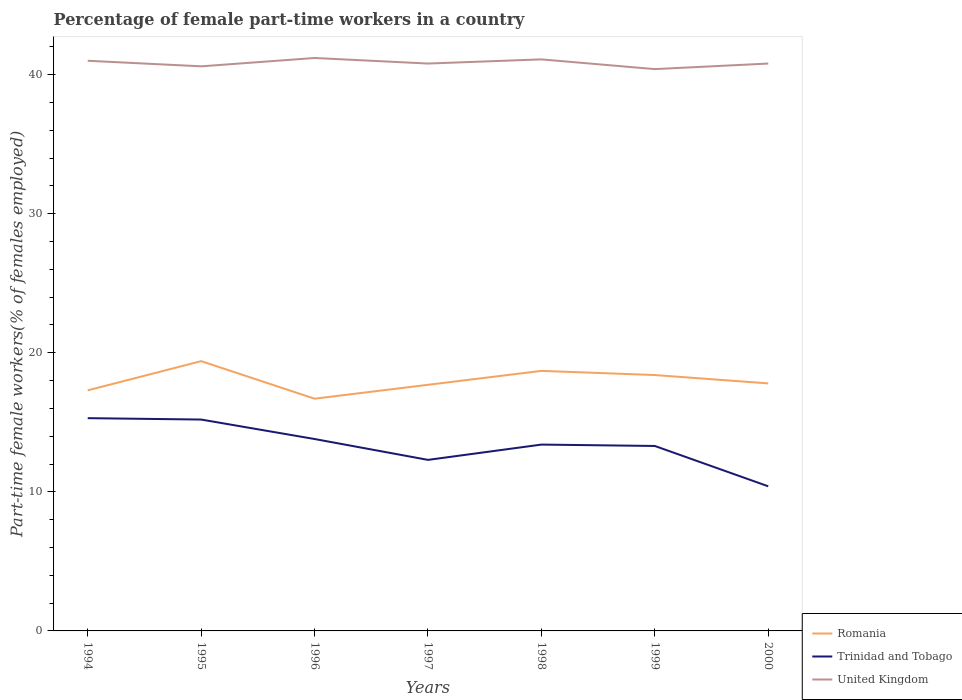Does the line corresponding to Trinidad and Tobago intersect with the line corresponding to Romania?
Provide a short and direct response. No. Is the number of lines equal to the number of legend labels?
Your response must be concise. Yes. Across all years, what is the maximum percentage of female part-time workers in Trinidad and Tobago?
Offer a very short reply. 10.4. In which year was the percentage of female part-time workers in Romania maximum?
Your answer should be compact. 1996. What is the total percentage of female part-time workers in United Kingdom in the graph?
Provide a short and direct response. -0.6. What is the difference between the highest and the second highest percentage of female part-time workers in Trinidad and Tobago?
Your answer should be very brief. 4.9. What is the difference between the highest and the lowest percentage of female part-time workers in Trinidad and Tobago?
Offer a terse response. 4. What is the difference between two consecutive major ticks on the Y-axis?
Give a very brief answer. 10. Are the values on the major ticks of Y-axis written in scientific E-notation?
Ensure brevity in your answer.  No. Does the graph contain grids?
Provide a short and direct response. No. How many legend labels are there?
Your answer should be compact. 3. What is the title of the graph?
Make the answer very short. Percentage of female part-time workers in a country. What is the label or title of the Y-axis?
Provide a succinct answer. Part-time female workers(% of females employed). What is the Part-time female workers(% of females employed) of Romania in 1994?
Ensure brevity in your answer.  17.3. What is the Part-time female workers(% of females employed) in Trinidad and Tobago in 1994?
Your answer should be compact. 15.3. What is the Part-time female workers(% of females employed) in Romania in 1995?
Provide a short and direct response. 19.4. What is the Part-time female workers(% of females employed) of Trinidad and Tobago in 1995?
Provide a succinct answer. 15.2. What is the Part-time female workers(% of females employed) of United Kingdom in 1995?
Your response must be concise. 40.6. What is the Part-time female workers(% of females employed) of Romania in 1996?
Ensure brevity in your answer.  16.7. What is the Part-time female workers(% of females employed) in Trinidad and Tobago in 1996?
Provide a short and direct response. 13.8. What is the Part-time female workers(% of females employed) in United Kingdom in 1996?
Your answer should be compact. 41.2. What is the Part-time female workers(% of females employed) in Romania in 1997?
Make the answer very short. 17.7. What is the Part-time female workers(% of females employed) of Trinidad and Tobago in 1997?
Your answer should be compact. 12.3. What is the Part-time female workers(% of females employed) in United Kingdom in 1997?
Make the answer very short. 40.8. What is the Part-time female workers(% of females employed) of Romania in 1998?
Your answer should be very brief. 18.7. What is the Part-time female workers(% of females employed) of Trinidad and Tobago in 1998?
Provide a succinct answer. 13.4. What is the Part-time female workers(% of females employed) in United Kingdom in 1998?
Keep it short and to the point. 41.1. What is the Part-time female workers(% of females employed) in Romania in 1999?
Give a very brief answer. 18.4. What is the Part-time female workers(% of females employed) of Trinidad and Tobago in 1999?
Offer a terse response. 13.3. What is the Part-time female workers(% of females employed) in United Kingdom in 1999?
Provide a succinct answer. 40.4. What is the Part-time female workers(% of females employed) of Romania in 2000?
Keep it short and to the point. 17.8. What is the Part-time female workers(% of females employed) of Trinidad and Tobago in 2000?
Provide a succinct answer. 10.4. What is the Part-time female workers(% of females employed) of United Kingdom in 2000?
Ensure brevity in your answer.  40.8. Across all years, what is the maximum Part-time female workers(% of females employed) of Romania?
Your response must be concise. 19.4. Across all years, what is the maximum Part-time female workers(% of females employed) of Trinidad and Tobago?
Make the answer very short. 15.3. Across all years, what is the maximum Part-time female workers(% of females employed) in United Kingdom?
Your response must be concise. 41.2. Across all years, what is the minimum Part-time female workers(% of females employed) in Romania?
Your answer should be compact. 16.7. Across all years, what is the minimum Part-time female workers(% of females employed) in Trinidad and Tobago?
Your answer should be compact. 10.4. Across all years, what is the minimum Part-time female workers(% of females employed) in United Kingdom?
Provide a short and direct response. 40.4. What is the total Part-time female workers(% of females employed) in Romania in the graph?
Your answer should be compact. 126. What is the total Part-time female workers(% of females employed) of Trinidad and Tobago in the graph?
Make the answer very short. 93.7. What is the total Part-time female workers(% of females employed) in United Kingdom in the graph?
Make the answer very short. 285.9. What is the difference between the Part-time female workers(% of females employed) in Romania in 1994 and that in 1995?
Your response must be concise. -2.1. What is the difference between the Part-time female workers(% of females employed) of Trinidad and Tobago in 1994 and that in 1995?
Offer a very short reply. 0.1. What is the difference between the Part-time female workers(% of females employed) in United Kingdom in 1994 and that in 1995?
Your answer should be very brief. 0.4. What is the difference between the Part-time female workers(% of females employed) of United Kingdom in 1994 and that in 1997?
Provide a short and direct response. 0.2. What is the difference between the Part-time female workers(% of females employed) of Romania in 1994 and that in 1998?
Offer a very short reply. -1.4. What is the difference between the Part-time female workers(% of females employed) in Trinidad and Tobago in 1994 and that in 1998?
Keep it short and to the point. 1.9. What is the difference between the Part-time female workers(% of females employed) in United Kingdom in 1994 and that in 1998?
Offer a terse response. -0.1. What is the difference between the Part-time female workers(% of females employed) in Romania in 1994 and that in 2000?
Provide a short and direct response. -0.5. What is the difference between the Part-time female workers(% of females employed) in United Kingdom in 1994 and that in 2000?
Keep it short and to the point. 0.2. What is the difference between the Part-time female workers(% of females employed) of Romania in 1995 and that in 1996?
Your answer should be very brief. 2.7. What is the difference between the Part-time female workers(% of females employed) in Trinidad and Tobago in 1995 and that in 1996?
Your answer should be compact. 1.4. What is the difference between the Part-time female workers(% of females employed) in United Kingdom in 1995 and that in 1996?
Your response must be concise. -0.6. What is the difference between the Part-time female workers(% of females employed) in Trinidad and Tobago in 1995 and that in 1997?
Offer a terse response. 2.9. What is the difference between the Part-time female workers(% of females employed) of Romania in 1995 and that in 1998?
Offer a very short reply. 0.7. What is the difference between the Part-time female workers(% of females employed) in Trinidad and Tobago in 1995 and that in 1999?
Your response must be concise. 1.9. What is the difference between the Part-time female workers(% of females employed) of United Kingdom in 1995 and that in 1999?
Your answer should be very brief. 0.2. What is the difference between the Part-time female workers(% of females employed) of Trinidad and Tobago in 1995 and that in 2000?
Offer a very short reply. 4.8. What is the difference between the Part-time female workers(% of females employed) of United Kingdom in 1995 and that in 2000?
Offer a terse response. -0.2. What is the difference between the Part-time female workers(% of females employed) of Trinidad and Tobago in 1996 and that in 1998?
Provide a short and direct response. 0.4. What is the difference between the Part-time female workers(% of females employed) of Trinidad and Tobago in 1996 and that in 1999?
Offer a very short reply. 0.5. What is the difference between the Part-time female workers(% of females employed) in Romania in 1996 and that in 2000?
Your response must be concise. -1.1. What is the difference between the Part-time female workers(% of females employed) in Trinidad and Tobago in 1996 and that in 2000?
Your response must be concise. 3.4. What is the difference between the Part-time female workers(% of females employed) of Trinidad and Tobago in 1997 and that in 1998?
Your answer should be compact. -1.1. What is the difference between the Part-time female workers(% of females employed) in Romania in 1997 and that in 1999?
Give a very brief answer. -0.7. What is the difference between the Part-time female workers(% of females employed) in Trinidad and Tobago in 1997 and that in 1999?
Provide a short and direct response. -1. What is the difference between the Part-time female workers(% of females employed) of Romania in 1997 and that in 2000?
Provide a succinct answer. -0.1. What is the difference between the Part-time female workers(% of females employed) of United Kingdom in 1998 and that in 1999?
Ensure brevity in your answer.  0.7. What is the difference between the Part-time female workers(% of females employed) of Romania in 1998 and that in 2000?
Offer a very short reply. 0.9. What is the difference between the Part-time female workers(% of females employed) in Romania in 1994 and the Part-time female workers(% of females employed) in United Kingdom in 1995?
Your response must be concise. -23.3. What is the difference between the Part-time female workers(% of females employed) of Trinidad and Tobago in 1994 and the Part-time female workers(% of females employed) of United Kingdom in 1995?
Provide a succinct answer. -25.3. What is the difference between the Part-time female workers(% of females employed) of Romania in 1994 and the Part-time female workers(% of females employed) of United Kingdom in 1996?
Provide a short and direct response. -23.9. What is the difference between the Part-time female workers(% of females employed) in Trinidad and Tobago in 1994 and the Part-time female workers(% of females employed) in United Kingdom in 1996?
Offer a terse response. -25.9. What is the difference between the Part-time female workers(% of females employed) in Romania in 1994 and the Part-time female workers(% of females employed) in United Kingdom in 1997?
Provide a succinct answer. -23.5. What is the difference between the Part-time female workers(% of females employed) of Trinidad and Tobago in 1994 and the Part-time female workers(% of females employed) of United Kingdom in 1997?
Provide a succinct answer. -25.5. What is the difference between the Part-time female workers(% of females employed) of Romania in 1994 and the Part-time female workers(% of females employed) of Trinidad and Tobago in 1998?
Your answer should be compact. 3.9. What is the difference between the Part-time female workers(% of females employed) in Romania in 1994 and the Part-time female workers(% of females employed) in United Kingdom in 1998?
Your response must be concise. -23.8. What is the difference between the Part-time female workers(% of females employed) in Trinidad and Tobago in 1994 and the Part-time female workers(% of females employed) in United Kingdom in 1998?
Provide a short and direct response. -25.8. What is the difference between the Part-time female workers(% of females employed) in Romania in 1994 and the Part-time female workers(% of females employed) in Trinidad and Tobago in 1999?
Your answer should be very brief. 4. What is the difference between the Part-time female workers(% of females employed) of Romania in 1994 and the Part-time female workers(% of females employed) of United Kingdom in 1999?
Give a very brief answer. -23.1. What is the difference between the Part-time female workers(% of females employed) in Trinidad and Tobago in 1994 and the Part-time female workers(% of females employed) in United Kingdom in 1999?
Give a very brief answer. -25.1. What is the difference between the Part-time female workers(% of females employed) in Romania in 1994 and the Part-time female workers(% of females employed) in Trinidad and Tobago in 2000?
Provide a short and direct response. 6.9. What is the difference between the Part-time female workers(% of females employed) in Romania in 1994 and the Part-time female workers(% of females employed) in United Kingdom in 2000?
Give a very brief answer. -23.5. What is the difference between the Part-time female workers(% of females employed) in Trinidad and Tobago in 1994 and the Part-time female workers(% of females employed) in United Kingdom in 2000?
Your response must be concise. -25.5. What is the difference between the Part-time female workers(% of females employed) in Romania in 1995 and the Part-time female workers(% of females employed) in United Kingdom in 1996?
Your answer should be compact. -21.8. What is the difference between the Part-time female workers(% of females employed) in Trinidad and Tobago in 1995 and the Part-time female workers(% of females employed) in United Kingdom in 1996?
Ensure brevity in your answer.  -26. What is the difference between the Part-time female workers(% of females employed) of Romania in 1995 and the Part-time female workers(% of females employed) of Trinidad and Tobago in 1997?
Offer a very short reply. 7.1. What is the difference between the Part-time female workers(% of females employed) in Romania in 1995 and the Part-time female workers(% of females employed) in United Kingdom in 1997?
Give a very brief answer. -21.4. What is the difference between the Part-time female workers(% of females employed) of Trinidad and Tobago in 1995 and the Part-time female workers(% of females employed) of United Kingdom in 1997?
Provide a short and direct response. -25.6. What is the difference between the Part-time female workers(% of females employed) of Romania in 1995 and the Part-time female workers(% of females employed) of United Kingdom in 1998?
Keep it short and to the point. -21.7. What is the difference between the Part-time female workers(% of females employed) of Trinidad and Tobago in 1995 and the Part-time female workers(% of females employed) of United Kingdom in 1998?
Make the answer very short. -25.9. What is the difference between the Part-time female workers(% of females employed) of Romania in 1995 and the Part-time female workers(% of females employed) of Trinidad and Tobago in 1999?
Provide a short and direct response. 6.1. What is the difference between the Part-time female workers(% of females employed) in Romania in 1995 and the Part-time female workers(% of females employed) in United Kingdom in 1999?
Provide a short and direct response. -21. What is the difference between the Part-time female workers(% of females employed) in Trinidad and Tobago in 1995 and the Part-time female workers(% of females employed) in United Kingdom in 1999?
Your answer should be compact. -25.2. What is the difference between the Part-time female workers(% of females employed) in Romania in 1995 and the Part-time female workers(% of females employed) in Trinidad and Tobago in 2000?
Provide a short and direct response. 9. What is the difference between the Part-time female workers(% of females employed) in Romania in 1995 and the Part-time female workers(% of females employed) in United Kingdom in 2000?
Make the answer very short. -21.4. What is the difference between the Part-time female workers(% of females employed) in Trinidad and Tobago in 1995 and the Part-time female workers(% of females employed) in United Kingdom in 2000?
Ensure brevity in your answer.  -25.6. What is the difference between the Part-time female workers(% of females employed) of Romania in 1996 and the Part-time female workers(% of females employed) of United Kingdom in 1997?
Offer a very short reply. -24.1. What is the difference between the Part-time female workers(% of females employed) in Trinidad and Tobago in 1996 and the Part-time female workers(% of females employed) in United Kingdom in 1997?
Keep it short and to the point. -27. What is the difference between the Part-time female workers(% of females employed) in Romania in 1996 and the Part-time female workers(% of females employed) in Trinidad and Tobago in 1998?
Offer a terse response. 3.3. What is the difference between the Part-time female workers(% of females employed) of Romania in 1996 and the Part-time female workers(% of females employed) of United Kingdom in 1998?
Your answer should be very brief. -24.4. What is the difference between the Part-time female workers(% of females employed) in Trinidad and Tobago in 1996 and the Part-time female workers(% of females employed) in United Kingdom in 1998?
Your answer should be compact. -27.3. What is the difference between the Part-time female workers(% of females employed) of Romania in 1996 and the Part-time female workers(% of females employed) of Trinidad and Tobago in 1999?
Keep it short and to the point. 3.4. What is the difference between the Part-time female workers(% of females employed) of Romania in 1996 and the Part-time female workers(% of females employed) of United Kingdom in 1999?
Offer a terse response. -23.7. What is the difference between the Part-time female workers(% of females employed) in Trinidad and Tobago in 1996 and the Part-time female workers(% of females employed) in United Kingdom in 1999?
Provide a short and direct response. -26.6. What is the difference between the Part-time female workers(% of females employed) in Romania in 1996 and the Part-time female workers(% of females employed) in Trinidad and Tobago in 2000?
Offer a very short reply. 6.3. What is the difference between the Part-time female workers(% of females employed) in Romania in 1996 and the Part-time female workers(% of females employed) in United Kingdom in 2000?
Provide a short and direct response. -24.1. What is the difference between the Part-time female workers(% of females employed) of Romania in 1997 and the Part-time female workers(% of females employed) of Trinidad and Tobago in 1998?
Give a very brief answer. 4.3. What is the difference between the Part-time female workers(% of females employed) in Romania in 1997 and the Part-time female workers(% of females employed) in United Kingdom in 1998?
Your answer should be compact. -23.4. What is the difference between the Part-time female workers(% of females employed) of Trinidad and Tobago in 1997 and the Part-time female workers(% of females employed) of United Kingdom in 1998?
Your answer should be very brief. -28.8. What is the difference between the Part-time female workers(% of females employed) in Romania in 1997 and the Part-time female workers(% of females employed) in Trinidad and Tobago in 1999?
Make the answer very short. 4.4. What is the difference between the Part-time female workers(% of females employed) of Romania in 1997 and the Part-time female workers(% of females employed) of United Kingdom in 1999?
Ensure brevity in your answer.  -22.7. What is the difference between the Part-time female workers(% of females employed) in Trinidad and Tobago in 1997 and the Part-time female workers(% of females employed) in United Kingdom in 1999?
Provide a short and direct response. -28.1. What is the difference between the Part-time female workers(% of females employed) of Romania in 1997 and the Part-time female workers(% of females employed) of Trinidad and Tobago in 2000?
Keep it short and to the point. 7.3. What is the difference between the Part-time female workers(% of females employed) in Romania in 1997 and the Part-time female workers(% of females employed) in United Kingdom in 2000?
Keep it short and to the point. -23.1. What is the difference between the Part-time female workers(% of females employed) in Trinidad and Tobago in 1997 and the Part-time female workers(% of females employed) in United Kingdom in 2000?
Offer a very short reply. -28.5. What is the difference between the Part-time female workers(% of females employed) of Romania in 1998 and the Part-time female workers(% of females employed) of United Kingdom in 1999?
Ensure brevity in your answer.  -21.7. What is the difference between the Part-time female workers(% of females employed) of Trinidad and Tobago in 1998 and the Part-time female workers(% of females employed) of United Kingdom in 1999?
Make the answer very short. -27. What is the difference between the Part-time female workers(% of females employed) in Romania in 1998 and the Part-time female workers(% of females employed) in Trinidad and Tobago in 2000?
Offer a very short reply. 8.3. What is the difference between the Part-time female workers(% of females employed) in Romania in 1998 and the Part-time female workers(% of females employed) in United Kingdom in 2000?
Give a very brief answer. -22.1. What is the difference between the Part-time female workers(% of females employed) in Trinidad and Tobago in 1998 and the Part-time female workers(% of females employed) in United Kingdom in 2000?
Provide a succinct answer. -27.4. What is the difference between the Part-time female workers(% of females employed) of Romania in 1999 and the Part-time female workers(% of females employed) of Trinidad and Tobago in 2000?
Your answer should be compact. 8. What is the difference between the Part-time female workers(% of females employed) in Romania in 1999 and the Part-time female workers(% of females employed) in United Kingdom in 2000?
Your answer should be very brief. -22.4. What is the difference between the Part-time female workers(% of females employed) of Trinidad and Tobago in 1999 and the Part-time female workers(% of females employed) of United Kingdom in 2000?
Your answer should be very brief. -27.5. What is the average Part-time female workers(% of females employed) of Trinidad and Tobago per year?
Give a very brief answer. 13.39. What is the average Part-time female workers(% of females employed) of United Kingdom per year?
Your answer should be very brief. 40.84. In the year 1994, what is the difference between the Part-time female workers(% of females employed) of Romania and Part-time female workers(% of females employed) of United Kingdom?
Your answer should be very brief. -23.7. In the year 1994, what is the difference between the Part-time female workers(% of females employed) in Trinidad and Tobago and Part-time female workers(% of females employed) in United Kingdom?
Offer a very short reply. -25.7. In the year 1995, what is the difference between the Part-time female workers(% of females employed) of Romania and Part-time female workers(% of females employed) of United Kingdom?
Provide a short and direct response. -21.2. In the year 1995, what is the difference between the Part-time female workers(% of females employed) in Trinidad and Tobago and Part-time female workers(% of females employed) in United Kingdom?
Provide a succinct answer. -25.4. In the year 1996, what is the difference between the Part-time female workers(% of females employed) of Romania and Part-time female workers(% of females employed) of Trinidad and Tobago?
Offer a very short reply. 2.9. In the year 1996, what is the difference between the Part-time female workers(% of females employed) in Romania and Part-time female workers(% of females employed) in United Kingdom?
Give a very brief answer. -24.5. In the year 1996, what is the difference between the Part-time female workers(% of females employed) in Trinidad and Tobago and Part-time female workers(% of females employed) in United Kingdom?
Offer a terse response. -27.4. In the year 1997, what is the difference between the Part-time female workers(% of females employed) of Romania and Part-time female workers(% of females employed) of United Kingdom?
Make the answer very short. -23.1. In the year 1997, what is the difference between the Part-time female workers(% of females employed) of Trinidad and Tobago and Part-time female workers(% of females employed) of United Kingdom?
Keep it short and to the point. -28.5. In the year 1998, what is the difference between the Part-time female workers(% of females employed) of Romania and Part-time female workers(% of females employed) of Trinidad and Tobago?
Offer a terse response. 5.3. In the year 1998, what is the difference between the Part-time female workers(% of females employed) in Romania and Part-time female workers(% of females employed) in United Kingdom?
Give a very brief answer. -22.4. In the year 1998, what is the difference between the Part-time female workers(% of females employed) in Trinidad and Tobago and Part-time female workers(% of females employed) in United Kingdom?
Offer a terse response. -27.7. In the year 1999, what is the difference between the Part-time female workers(% of females employed) in Trinidad and Tobago and Part-time female workers(% of females employed) in United Kingdom?
Provide a succinct answer. -27.1. In the year 2000, what is the difference between the Part-time female workers(% of females employed) in Romania and Part-time female workers(% of females employed) in United Kingdom?
Ensure brevity in your answer.  -23. In the year 2000, what is the difference between the Part-time female workers(% of females employed) of Trinidad and Tobago and Part-time female workers(% of females employed) of United Kingdom?
Provide a succinct answer. -30.4. What is the ratio of the Part-time female workers(% of females employed) of Romania in 1994 to that in 1995?
Ensure brevity in your answer.  0.89. What is the ratio of the Part-time female workers(% of females employed) in Trinidad and Tobago in 1994 to that in 1995?
Provide a succinct answer. 1.01. What is the ratio of the Part-time female workers(% of females employed) of United Kingdom in 1994 to that in 1995?
Give a very brief answer. 1.01. What is the ratio of the Part-time female workers(% of females employed) in Romania in 1994 to that in 1996?
Your response must be concise. 1.04. What is the ratio of the Part-time female workers(% of females employed) of Trinidad and Tobago in 1994 to that in 1996?
Make the answer very short. 1.11. What is the ratio of the Part-time female workers(% of females employed) in United Kingdom in 1994 to that in 1996?
Give a very brief answer. 1. What is the ratio of the Part-time female workers(% of females employed) in Romania in 1994 to that in 1997?
Keep it short and to the point. 0.98. What is the ratio of the Part-time female workers(% of females employed) of Trinidad and Tobago in 1994 to that in 1997?
Offer a very short reply. 1.24. What is the ratio of the Part-time female workers(% of females employed) in United Kingdom in 1994 to that in 1997?
Your response must be concise. 1. What is the ratio of the Part-time female workers(% of females employed) in Romania in 1994 to that in 1998?
Ensure brevity in your answer.  0.93. What is the ratio of the Part-time female workers(% of females employed) in Trinidad and Tobago in 1994 to that in 1998?
Ensure brevity in your answer.  1.14. What is the ratio of the Part-time female workers(% of females employed) of Romania in 1994 to that in 1999?
Give a very brief answer. 0.94. What is the ratio of the Part-time female workers(% of females employed) in Trinidad and Tobago in 1994 to that in 1999?
Your answer should be compact. 1.15. What is the ratio of the Part-time female workers(% of females employed) of United Kingdom in 1994 to that in 1999?
Make the answer very short. 1.01. What is the ratio of the Part-time female workers(% of females employed) of Romania in 1994 to that in 2000?
Make the answer very short. 0.97. What is the ratio of the Part-time female workers(% of females employed) of Trinidad and Tobago in 1994 to that in 2000?
Provide a succinct answer. 1.47. What is the ratio of the Part-time female workers(% of females employed) in Romania in 1995 to that in 1996?
Offer a very short reply. 1.16. What is the ratio of the Part-time female workers(% of females employed) of Trinidad and Tobago in 1995 to that in 1996?
Offer a very short reply. 1.1. What is the ratio of the Part-time female workers(% of females employed) in United Kingdom in 1995 to that in 1996?
Provide a short and direct response. 0.99. What is the ratio of the Part-time female workers(% of females employed) of Romania in 1995 to that in 1997?
Offer a terse response. 1.1. What is the ratio of the Part-time female workers(% of females employed) in Trinidad and Tobago in 1995 to that in 1997?
Provide a succinct answer. 1.24. What is the ratio of the Part-time female workers(% of females employed) of Romania in 1995 to that in 1998?
Ensure brevity in your answer.  1.04. What is the ratio of the Part-time female workers(% of females employed) of Trinidad and Tobago in 1995 to that in 1998?
Offer a very short reply. 1.13. What is the ratio of the Part-time female workers(% of females employed) in Romania in 1995 to that in 1999?
Make the answer very short. 1.05. What is the ratio of the Part-time female workers(% of females employed) of Trinidad and Tobago in 1995 to that in 1999?
Make the answer very short. 1.14. What is the ratio of the Part-time female workers(% of females employed) in Romania in 1995 to that in 2000?
Provide a short and direct response. 1.09. What is the ratio of the Part-time female workers(% of females employed) in Trinidad and Tobago in 1995 to that in 2000?
Make the answer very short. 1.46. What is the ratio of the Part-time female workers(% of females employed) of United Kingdom in 1995 to that in 2000?
Offer a very short reply. 1. What is the ratio of the Part-time female workers(% of females employed) of Romania in 1996 to that in 1997?
Your answer should be very brief. 0.94. What is the ratio of the Part-time female workers(% of females employed) of Trinidad and Tobago in 1996 to that in 1997?
Your response must be concise. 1.12. What is the ratio of the Part-time female workers(% of females employed) in United Kingdom in 1996 to that in 1997?
Keep it short and to the point. 1.01. What is the ratio of the Part-time female workers(% of females employed) in Romania in 1996 to that in 1998?
Keep it short and to the point. 0.89. What is the ratio of the Part-time female workers(% of females employed) of Trinidad and Tobago in 1996 to that in 1998?
Offer a terse response. 1.03. What is the ratio of the Part-time female workers(% of females employed) in United Kingdom in 1996 to that in 1998?
Your answer should be very brief. 1. What is the ratio of the Part-time female workers(% of females employed) in Romania in 1996 to that in 1999?
Ensure brevity in your answer.  0.91. What is the ratio of the Part-time female workers(% of females employed) in Trinidad and Tobago in 1996 to that in 1999?
Keep it short and to the point. 1.04. What is the ratio of the Part-time female workers(% of females employed) in United Kingdom in 1996 to that in 1999?
Your answer should be very brief. 1.02. What is the ratio of the Part-time female workers(% of females employed) of Romania in 1996 to that in 2000?
Your answer should be compact. 0.94. What is the ratio of the Part-time female workers(% of females employed) of Trinidad and Tobago in 1996 to that in 2000?
Keep it short and to the point. 1.33. What is the ratio of the Part-time female workers(% of females employed) of United Kingdom in 1996 to that in 2000?
Offer a terse response. 1.01. What is the ratio of the Part-time female workers(% of females employed) of Romania in 1997 to that in 1998?
Your response must be concise. 0.95. What is the ratio of the Part-time female workers(% of females employed) of Trinidad and Tobago in 1997 to that in 1998?
Your answer should be compact. 0.92. What is the ratio of the Part-time female workers(% of females employed) of United Kingdom in 1997 to that in 1998?
Your answer should be compact. 0.99. What is the ratio of the Part-time female workers(% of females employed) of Romania in 1997 to that in 1999?
Give a very brief answer. 0.96. What is the ratio of the Part-time female workers(% of females employed) in Trinidad and Tobago in 1997 to that in 1999?
Provide a short and direct response. 0.92. What is the ratio of the Part-time female workers(% of females employed) of United Kingdom in 1997 to that in 1999?
Provide a short and direct response. 1.01. What is the ratio of the Part-time female workers(% of females employed) in Romania in 1997 to that in 2000?
Your answer should be compact. 0.99. What is the ratio of the Part-time female workers(% of females employed) of Trinidad and Tobago in 1997 to that in 2000?
Your answer should be compact. 1.18. What is the ratio of the Part-time female workers(% of females employed) in United Kingdom in 1997 to that in 2000?
Offer a very short reply. 1. What is the ratio of the Part-time female workers(% of females employed) of Romania in 1998 to that in 1999?
Offer a terse response. 1.02. What is the ratio of the Part-time female workers(% of females employed) of Trinidad and Tobago in 1998 to that in 1999?
Provide a succinct answer. 1.01. What is the ratio of the Part-time female workers(% of females employed) in United Kingdom in 1998 to that in 1999?
Your answer should be compact. 1.02. What is the ratio of the Part-time female workers(% of females employed) in Romania in 1998 to that in 2000?
Keep it short and to the point. 1.05. What is the ratio of the Part-time female workers(% of females employed) in Trinidad and Tobago in 1998 to that in 2000?
Provide a succinct answer. 1.29. What is the ratio of the Part-time female workers(% of females employed) in United Kingdom in 1998 to that in 2000?
Offer a very short reply. 1.01. What is the ratio of the Part-time female workers(% of females employed) in Romania in 1999 to that in 2000?
Provide a short and direct response. 1.03. What is the ratio of the Part-time female workers(% of females employed) of Trinidad and Tobago in 1999 to that in 2000?
Give a very brief answer. 1.28. What is the ratio of the Part-time female workers(% of females employed) of United Kingdom in 1999 to that in 2000?
Provide a short and direct response. 0.99. What is the difference between the highest and the second highest Part-time female workers(% of females employed) in Trinidad and Tobago?
Your response must be concise. 0.1. What is the difference between the highest and the second highest Part-time female workers(% of females employed) in United Kingdom?
Your answer should be very brief. 0.1. What is the difference between the highest and the lowest Part-time female workers(% of females employed) in Romania?
Ensure brevity in your answer.  2.7. What is the difference between the highest and the lowest Part-time female workers(% of females employed) in Trinidad and Tobago?
Your answer should be compact. 4.9. 